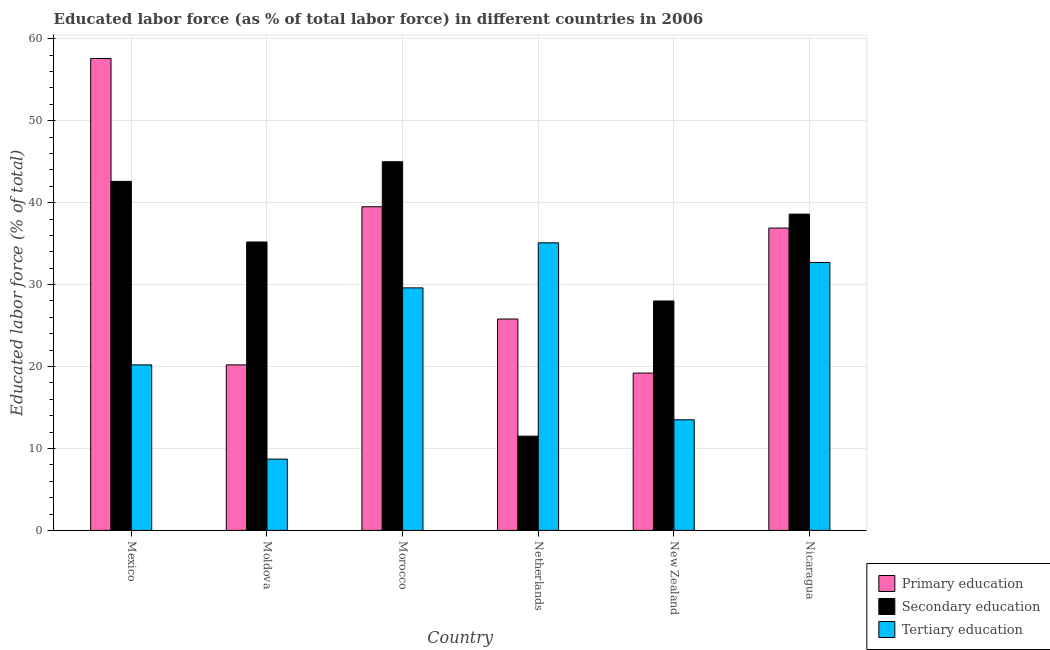How many different coloured bars are there?
Your answer should be compact. 3. How many groups of bars are there?
Provide a short and direct response. 6. Are the number of bars per tick equal to the number of legend labels?
Offer a terse response. Yes. How many bars are there on the 4th tick from the right?
Your response must be concise. 3. In how many cases, is the number of bars for a given country not equal to the number of legend labels?
Give a very brief answer. 0. What is the percentage of labor force who received tertiary education in Moldova?
Your answer should be compact. 8.7. Across all countries, what is the maximum percentage of labor force who received tertiary education?
Give a very brief answer. 35.1. Across all countries, what is the minimum percentage of labor force who received primary education?
Keep it short and to the point. 19.2. In which country was the percentage of labor force who received primary education minimum?
Make the answer very short. New Zealand. What is the total percentage of labor force who received primary education in the graph?
Offer a very short reply. 199.2. What is the difference between the percentage of labor force who received primary education in Mexico and that in Netherlands?
Make the answer very short. 31.8. What is the difference between the percentage of labor force who received secondary education in Mexico and the percentage of labor force who received primary education in Netherlands?
Make the answer very short. 16.8. What is the average percentage of labor force who received tertiary education per country?
Provide a short and direct response. 23.3. What is the difference between the percentage of labor force who received secondary education and percentage of labor force who received tertiary education in Morocco?
Ensure brevity in your answer.  15.4. What is the ratio of the percentage of labor force who received tertiary education in Moldova to that in Netherlands?
Ensure brevity in your answer.  0.25. Is the percentage of labor force who received secondary education in Mexico less than that in Netherlands?
Ensure brevity in your answer.  No. Is the difference between the percentage of labor force who received primary education in Moldova and Nicaragua greater than the difference between the percentage of labor force who received tertiary education in Moldova and Nicaragua?
Provide a succinct answer. Yes. What is the difference between the highest and the second highest percentage of labor force who received secondary education?
Your answer should be very brief. 2.4. What is the difference between the highest and the lowest percentage of labor force who received secondary education?
Keep it short and to the point. 33.5. In how many countries, is the percentage of labor force who received primary education greater than the average percentage of labor force who received primary education taken over all countries?
Your answer should be very brief. 3. Is the sum of the percentage of labor force who received secondary education in Mexico and Netherlands greater than the maximum percentage of labor force who received primary education across all countries?
Your response must be concise. No. What does the 2nd bar from the left in Mexico represents?
Make the answer very short. Secondary education. What does the 1st bar from the right in Netherlands represents?
Offer a terse response. Tertiary education. Are all the bars in the graph horizontal?
Your answer should be very brief. No. How many countries are there in the graph?
Offer a terse response. 6. Does the graph contain any zero values?
Provide a succinct answer. No. How are the legend labels stacked?
Offer a terse response. Vertical. What is the title of the graph?
Ensure brevity in your answer.  Educated labor force (as % of total labor force) in different countries in 2006. Does "Primary education" appear as one of the legend labels in the graph?
Ensure brevity in your answer.  Yes. What is the label or title of the Y-axis?
Give a very brief answer. Educated labor force (% of total). What is the Educated labor force (% of total) of Primary education in Mexico?
Ensure brevity in your answer.  57.6. What is the Educated labor force (% of total) of Secondary education in Mexico?
Provide a short and direct response. 42.6. What is the Educated labor force (% of total) in Tertiary education in Mexico?
Provide a short and direct response. 20.2. What is the Educated labor force (% of total) of Primary education in Moldova?
Offer a very short reply. 20.2. What is the Educated labor force (% of total) in Secondary education in Moldova?
Your answer should be very brief. 35.2. What is the Educated labor force (% of total) in Tertiary education in Moldova?
Offer a terse response. 8.7. What is the Educated labor force (% of total) of Primary education in Morocco?
Your answer should be very brief. 39.5. What is the Educated labor force (% of total) in Secondary education in Morocco?
Offer a terse response. 45. What is the Educated labor force (% of total) in Tertiary education in Morocco?
Your answer should be very brief. 29.6. What is the Educated labor force (% of total) of Primary education in Netherlands?
Offer a very short reply. 25.8. What is the Educated labor force (% of total) in Secondary education in Netherlands?
Make the answer very short. 11.5. What is the Educated labor force (% of total) of Tertiary education in Netherlands?
Your answer should be very brief. 35.1. What is the Educated labor force (% of total) in Primary education in New Zealand?
Your answer should be very brief. 19.2. What is the Educated labor force (% of total) in Secondary education in New Zealand?
Your response must be concise. 28. What is the Educated labor force (% of total) of Primary education in Nicaragua?
Keep it short and to the point. 36.9. What is the Educated labor force (% of total) of Secondary education in Nicaragua?
Give a very brief answer. 38.6. What is the Educated labor force (% of total) of Tertiary education in Nicaragua?
Give a very brief answer. 32.7. Across all countries, what is the maximum Educated labor force (% of total) of Primary education?
Offer a terse response. 57.6. Across all countries, what is the maximum Educated labor force (% of total) of Secondary education?
Offer a very short reply. 45. Across all countries, what is the maximum Educated labor force (% of total) in Tertiary education?
Make the answer very short. 35.1. Across all countries, what is the minimum Educated labor force (% of total) of Primary education?
Make the answer very short. 19.2. Across all countries, what is the minimum Educated labor force (% of total) in Secondary education?
Keep it short and to the point. 11.5. Across all countries, what is the minimum Educated labor force (% of total) in Tertiary education?
Provide a succinct answer. 8.7. What is the total Educated labor force (% of total) in Primary education in the graph?
Make the answer very short. 199.2. What is the total Educated labor force (% of total) of Secondary education in the graph?
Offer a very short reply. 200.9. What is the total Educated labor force (% of total) of Tertiary education in the graph?
Ensure brevity in your answer.  139.8. What is the difference between the Educated labor force (% of total) of Primary education in Mexico and that in Moldova?
Ensure brevity in your answer.  37.4. What is the difference between the Educated labor force (% of total) in Primary education in Mexico and that in Morocco?
Provide a succinct answer. 18.1. What is the difference between the Educated labor force (% of total) in Primary education in Mexico and that in Netherlands?
Give a very brief answer. 31.8. What is the difference between the Educated labor force (% of total) in Secondary education in Mexico and that in Netherlands?
Offer a terse response. 31.1. What is the difference between the Educated labor force (% of total) of Tertiary education in Mexico and that in Netherlands?
Your answer should be very brief. -14.9. What is the difference between the Educated labor force (% of total) of Primary education in Mexico and that in New Zealand?
Give a very brief answer. 38.4. What is the difference between the Educated labor force (% of total) in Secondary education in Mexico and that in New Zealand?
Give a very brief answer. 14.6. What is the difference between the Educated labor force (% of total) in Tertiary education in Mexico and that in New Zealand?
Ensure brevity in your answer.  6.7. What is the difference between the Educated labor force (% of total) in Primary education in Mexico and that in Nicaragua?
Keep it short and to the point. 20.7. What is the difference between the Educated labor force (% of total) in Tertiary education in Mexico and that in Nicaragua?
Provide a short and direct response. -12.5. What is the difference between the Educated labor force (% of total) of Primary education in Moldova and that in Morocco?
Make the answer very short. -19.3. What is the difference between the Educated labor force (% of total) of Secondary education in Moldova and that in Morocco?
Your response must be concise. -9.8. What is the difference between the Educated labor force (% of total) of Tertiary education in Moldova and that in Morocco?
Offer a terse response. -20.9. What is the difference between the Educated labor force (% of total) in Secondary education in Moldova and that in Netherlands?
Your answer should be compact. 23.7. What is the difference between the Educated labor force (% of total) of Tertiary education in Moldova and that in Netherlands?
Give a very brief answer. -26.4. What is the difference between the Educated labor force (% of total) of Secondary education in Moldova and that in New Zealand?
Ensure brevity in your answer.  7.2. What is the difference between the Educated labor force (% of total) of Primary education in Moldova and that in Nicaragua?
Your response must be concise. -16.7. What is the difference between the Educated labor force (% of total) in Secondary education in Morocco and that in Netherlands?
Provide a succinct answer. 33.5. What is the difference between the Educated labor force (% of total) of Primary education in Morocco and that in New Zealand?
Keep it short and to the point. 20.3. What is the difference between the Educated labor force (% of total) of Primary education in Morocco and that in Nicaragua?
Provide a short and direct response. 2.6. What is the difference between the Educated labor force (% of total) in Secondary education in Morocco and that in Nicaragua?
Ensure brevity in your answer.  6.4. What is the difference between the Educated labor force (% of total) of Tertiary education in Morocco and that in Nicaragua?
Your response must be concise. -3.1. What is the difference between the Educated labor force (% of total) in Primary education in Netherlands and that in New Zealand?
Give a very brief answer. 6.6. What is the difference between the Educated labor force (% of total) of Secondary education in Netherlands and that in New Zealand?
Your answer should be very brief. -16.5. What is the difference between the Educated labor force (% of total) of Tertiary education in Netherlands and that in New Zealand?
Your response must be concise. 21.6. What is the difference between the Educated labor force (% of total) of Primary education in Netherlands and that in Nicaragua?
Give a very brief answer. -11.1. What is the difference between the Educated labor force (% of total) in Secondary education in Netherlands and that in Nicaragua?
Your answer should be compact. -27.1. What is the difference between the Educated labor force (% of total) in Primary education in New Zealand and that in Nicaragua?
Your answer should be very brief. -17.7. What is the difference between the Educated labor force (% of total) of Secondary education in New Zealand and that in Nicaragua?
Offer a very short reply. -10.6. What is the difference between the Educated labor force (% of total) in Tertiary education in New Zealand and that in Nicaragua?
Keep it short and to the point. -19.2. What is the difference between the Educated labor force (% of total) of Primary education in Mexico and the Educated labor force (% of total) of Secondary education in Moldova?
Ensure brevity in your answer.  22.4. What is the difference between the Educated labor force (% of total) of Primary education in Mexico and the Educated labor force (% of total) of Tertiary education in Moldova?
Offer a terse response. 48.9. What is the difference between the Educated labor force (% of total) of Secondary education in Mexico and the Educated labor force (% of total) of Tertiary education in Moldova?
Offer a very short reply. 33.9. What is the difference between the Educated labor force (% of total) of Primary education in Mexico and the Educated labor force (% of total) of Tertiary education in Morocco?
Ensure brevity in your answer.  28. What is the difference between the Educated labor force (% of total) of Secondary education in Mexico and the Educated labor force (% of total) of Tertiary education in Morocco?
Offer a terse response. 13. What is the difference between the Educated labor force (% of total) of Primary education in Mexico and the Educated labor force (% of total) of Secondary education in Netherlands?
Ensure brevity in your answer.  46.1. What is the difference between the Educated labor force (% of total) in Secondary education in Mexico and the Educated labor force (% of total) in Tertiary education in Netherlands?
Offer a very short reply. 7.5. What is the difference between the Educated labor force (% of total) of Primary education in Mexico and the Educated labor force (% of total) of Secondary education in New Zealand?
Your response must be concise. 29.6. What is the difference between the Educated labor force (% of total) of Primary education in Mexico and the Educated labor force (% of total) of Tertiary education in New Zealand?
Offer a very short reply. 44.1. What is the difference between the Educated labor force (% of total) of Secondary education in Mexico and the Educated labor force (% of total) of Tertiary education in New Zealand?
Offer a very short reply. 29.1. What is the difference between the Educated labor force (% of total) of Primary education in Mexico and the Educated labor force (% of total) of Secondary education in Nicaragua?
Keep it short and to the point. 19. What is the difference between the Educated labor force (% of total) of Primary education in Mexico and the Educated labor force (% of total) of Tertiary education in Nicaragua?
Keep it short and to the point. 24.9. What is the difference between the Educated labor force (% of total) in Primary education in Moldova and the Educated labor force (% of total) in Secondary education in Morocco?
Give a very brief answer. -24.8. What is the difference between the Educated labor force (% of total) in Primary education in Moldova and the Educated labor force (% of total) in Tertiary education in Morocco?
Provide a short and direct response. -9.4. What is the difference between the Educated labor force (% of total) in Primary education in Moldova and the Educated labor force (% of total) in Secondary education in Netherlands?
Make the answer very short. 8.7. What is the difference between the Educated labor force (% of total) in Primary education in Moldova and the Educated labor force (% of total) in Tertiary education in Netherlands?
Provide a short and direct response. -14.9. What is the difference between the Educated labor force (% of total) of Primary education in Moldova and the Educated labor force (% of total) of Secondary education in New Zealand?
Offer a terse response. -7.8. What is the difference between the Educated labor force (% of total) in Primary education in Moldova and the Educated labor force (% of total) in Tertiary education in New Zealand?
Ensure brevity in your answer.  6.7. What is the difference between the Educated labor force (% of total) in Secondary education in Moldova and the Educated labor force (% of total) in Tertiary education in New Zealand?
Keep it short and to the point. 21.7. What is the difference between the Educated labor force (% of total) of Primary education in Moldova and the Educated labor force (% of total) of Secondary education in Nicaragua?
Your answer should be very brief. -18.4. What is the difference between the Educated labor force (% of total) in Secondary education in Moldova and the Educated labor force (% of total) in Tertiary education in Nicaragua?
Give a very brief answer. 2.5. What is the difference between the Educated labor force (% of total) of Primary education in Morocco and the Educated labor force (% of total) of Secondary education in New Zealand?
Provide a succinct answer. 11.5. What is the difference between the Educated labor force (% of total) in Secondary education in Morocco and the Educated labor force (% of total) in Tertiary education in New Zealand?
Provide a short and direct response. 31.5. What is the difference between the Educated labor force (% of total) in Secondary education in Morocco and the Educated labor force (% of total) in Tertiary education in Nicaragua?
Offer a very short reply. 12.3. What is the difference between the Educated labor force (% of total) of Primary education in Netherlands and the Educated labor force (% of total) of Secondary education in Nicaragua?
Make the answer very short. -12.8. What is the difference between the Educated labor force (% of total) in Secondary education in Netherlands and the Educated labor force (% of total) in Tertiary education in Nicaragua?
Your answer should be very brief. -21.2. What is the difference between the Educated labor force (% of total) in Primary education in New Zealand and the Educated labor force (% of total) in Secondary education in Nicaragua?
Provide a succinct answer. -19.4. What is the difference between the Educated labor force (% of total) of Primary education in New Zealand and the Educated labor force (% of total) of Tertiary education in Nicaragua?
Keep it short and to the point. -13.5. What is the difference between the Educated labor force (% of total) in Secondary education in New Zealand and the Educated labor force (% of total) in Tertiary education in Nicaragua?
Provide a short and direct response. -4.7. What is the average Educated labor force (% of total) of Primary education per country?
Give a very brief answer. 33.2. What is the average Educated labor force (% of total) of Secondary education per country?
Make the answer very short. 33.48. What is the average Educated labor force (% of total) of Tertiary education per country?
Offer a terse response. 23.3. What is the difference between the Educated labor force (% of total) in Primary education and Educated labor force (% of total) in Secondary education in Mexico?
Your answer should be compact. 15. What is the difference between the Educated labor force (% of total) of Primary education and Educated labor force (% of total) of Tertiary education in Mexico?
Provide a succinct answer. 37.4. What is the difference between the Educated labor force (% of total) in Secondary education and Educated labor force (% of total) in Tertiary education in Mexico?
Your answer should be compact. 22.4. What is the difference between the Educated labor force (% of total) of Primary education and Educated labor force (% of total) of Tertiary education in Morocco?
Your response must be concise. 9.9. What is the difference between the Educated labor force (% of total) of Primary education and Educated labor force (% of total) of Tertiary education in Netherlands?
Your response must be concise. -9.3. What is the difference between the Educated labor force (% of total) in Secondary education and Educated labor force (% of total) in Tertiary education in Netherlands?
Your response must be concise. -23.6. What is the difference between the Educated labor force (% of total) of Primary education and Educated labor force (% of total) of Secondary education in New Zealand?
Offer a very short reply. -8.8. What is the difference between the Educated labor force (% of total) in Secondary education and Educated labor force (% of total) in Tertiary education in New Zealand?
Offer a very short reply. 14.5. What is the difference between the Educated labor force (% of total) in Primary education and Educated labor force (% of total) in Tertiary education in Nicaragua?
Provide a succinct answer. 4.2. What is the ratio of the Educated labor force (% of total) in Primary education in Mexico to that in Moldova?
Provide a succinct answer. 2.85. What is the ratio of the Educated labor force (% of total) of Secondary education in Mexico to that in Moldova?
Your answer should be very brief. 1.21. What is the ratio of the Educated labor force (% of total) of Tertiary education in Mexico to that in Moldova?
Your answer should be compact. 2.32. What is the ratio of the Educated labor force (% of total) in Primary education in Mexico to that in Morocco?
Your answer should be compact. 1.46. What is the ratio of the Educated labor force (% of total) of Secondary education in Mexico to that in Morocco?
Make the answer very short. 0.95. What is the ratio of the Educated labor force (% of total) in Tertiary education in Mexico to that in Morocco?
Ensure brevity in your answer.  0.68. What is the ratio of the Educated labor force (% of total) in Primary education in Mexico to that in Netherlands?
Ensure brevity in your answer.  2.23. What is the ratio of the Educated labor force (% of total) of Secondary education in Mexico to that in Netherlands?
Keep it short and to the point. 3.7. What is the ratio of the Educated labor force (% of total) of Tertiary education in Mexico to that in Netherlands?
Your answer should be very brief. 0.58. What is the ratio of the Educated labor force (% of total) of Primary education in Mexico to that in New Zealand?
Provide a short and direct response. 3. What is the ratio of the Educated labor force (% of total) of Secondary education in Mexico to that in New Zealand?
Offer a very short reply. 1.52. What is the ratio of the Educated labor force (% of total) of Tertiary education in Mexico to that in New Zealand?
Your answer should be very brief. 1.5. What is the ratio of the Educated labor force (% of total) in Primary education in Mexico to that in Nicaragua?
Your answer should be compact. 1.56. What is the ratio of the Educated labor force (% of total) in Secondary education in Mexico to that in Nicaragua?
Provide a short and direct response. 1.1. What is the ratio of the Educated labor force (% of total) in Tertiary education in Mexico to that in Nicaragua?
Your response must be concise. 0.62. What is the ratio of the Educated labor force (% of total) in Primary education in Moldova to that in Morocco?
Ensure brevity in your answer.  0.51. What is the ratio of the Educated labor force (% of total) of Secondary education in Moldova to that in Morocco?
Make the answer very short. 0.78. What is the ratio of the Educated labor force (% of total) of Tertiary education in Moldova to that in Morocco?
Ensure brevity in your answer.  0.29. What is the ratio of the Educated labor force (% of total) of Primary education in Moldova to that in Netherlands?
Provide a succinct answer. 0.78. What is the ratio of the Educated labor force (% of total) in Secondary education in Moldova to that in Netherlands?
Offer a very short reply. 3.06. What is the ratio of the Educated labor force (% of total) in Tertiary education in Moldova to that in Netherlands?
Your answer should be compact. 0.25. What is the ratio of the Educated labor force (% of total) of Primary education in Moldova to that in New Zealand?
Keep it short and to the point. 1.05. What is the ratio of the Educated labor force (% of total) in Secondary education in Moldova to that in New Zealand?
Provide a succinct answer. 1.26. What is the ratio of the Educated labor force (% of total) in Tertiary education in Moldova to that in New Zealand?
Offer a very short reply. 0.64. What is the ratio of the Educated labor force (% of total) of Primary education in Moldova to that in Nicaragua?
Your response must be concise. 0.55. What is the ratio of the Educated labor force (% of total) of Secondary education in Moldova to that in Nicaragua?
Provide a short and direct response. 0.91. What is the ratio of the Educated labor force (% of total) of Tertiary education in Moldova to that in Nicaragua?
Provide a short and direct response. 0.27. What is the ratio of the Educated labor force (% of total) in Primary education in Morocco to that in Netherlands?
Ensure brevity in your answer.  1.53. What is the ratio of the Educated labor force (% of total) of Secondary education in Morocco to that in Netherlands?
Your answer should be compact. 3.91. What is the ratio of the Educated labor force (% of total) in Tertiary education in Morocco to that in Netherlands?
Your answer should be compact. 0.84. What is the ratio of the Educated labor force (% of total) in Primary education in Morocco to that in New Zealand?
Ensure brevity in your answer.  2.06. What is the ratio of the Educated labor force (% of total) in Secondary education in Morocco to that in New Zealand?
Offer a terse response. 1.61. What is the ratio of the Educated labor force (% of total) in Tertiary education in Morocco to that in New Zealand?
Provide a short and direct response. 2.19. What is the ratio of the Educated labor force (% of total) in Primary education in Morocco to that in Nicaragua?
Offer a very short reply. 1.07. What is the ratio of the Educated labor force (% of total) in Secondary education in Morocco to that in Nicaragua?
Make the answer very short. 1.17. What is the ratio of the Educated labor force (% of total) in Tertiary education in Morocco to that in Nicaragua?
Give a very brief answer. 0.91. What is the ratio of the Educated labor force (% of total) of Primary education in Netherlands to that in New Zealand?
Give a very brief answer. 1.34. What is the ratio of the Educated labor force (% of total) of Secondary education in Netherlands to that in New Zealand?
Give a very brief answer. 0.41. What is the ratio of the Educated labor force (% of total) of Tertiary education in Netherlands to that in New Zealand?
Give a very brief answer. 2.6. What is the ratio of the Educated labor force (% of total) of Primary education in Netherlands to that in Nicaragua?
Offer a terse response. 0.7. What is the ratio of the Educated labor force (% of total) in Secondary education in Netherlands to that in Nicaragua?
Your answer should be very brief. 0.3. What is the ratio of the Educated labor force (% of total) of Tertiary education in Netherlands to that in Nicaragua?
Your answer should be compact. 1.07. What is the ratio of the Educated labor force (% of total) in Primary education in New Zealand to that in Nicaragua?
Keep it short and to the point. 0.52. What is the ratio of the Educated labor force (% of total) in Secondary education in New Zealand to that in Nicaragua?
Provide a short and direct response. 0.73. What is the ratio of the Educated labor force (% of total) in Tertiary education in New Zealand to that in Nicaragua?
Keep it short and to the point. 0.41. What is the difference between the highest and the second highest Educated labor force (% of total) of Tertiary education?
Offer a terse response. 2.4. What is the difference between the highest and the lowest Educated labor force (% of total) of Primary education?
Offer a terse response. 38.4. What is the difference between the highest and the lowest Educated labor force (% of total) of Secondary education?
Make the answer very short. 33.5. What is the difference between the highest and the lowest Educated labor force (% of total) of Tertiary education?
Make the answer very short. 26.4. 